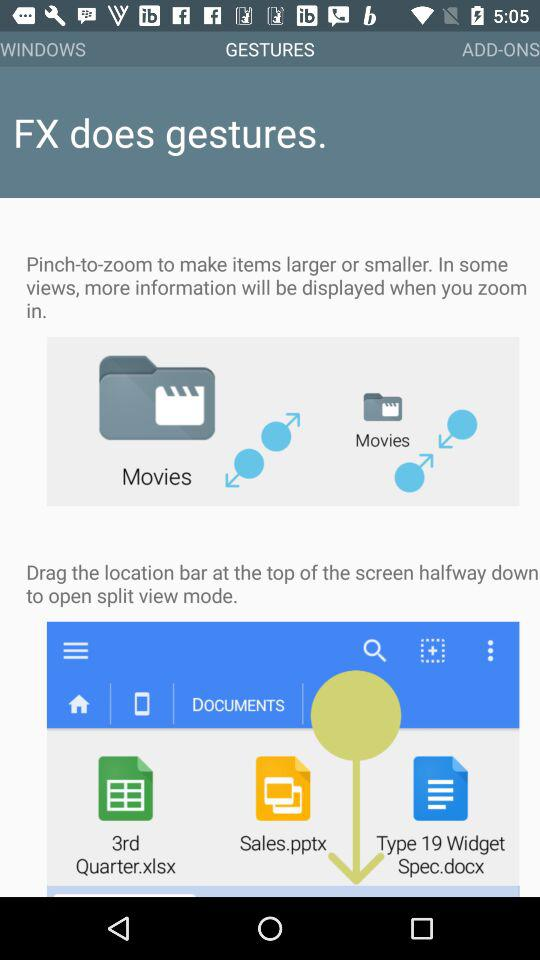Which tab is selected? The selected tab is "GESTURES". 